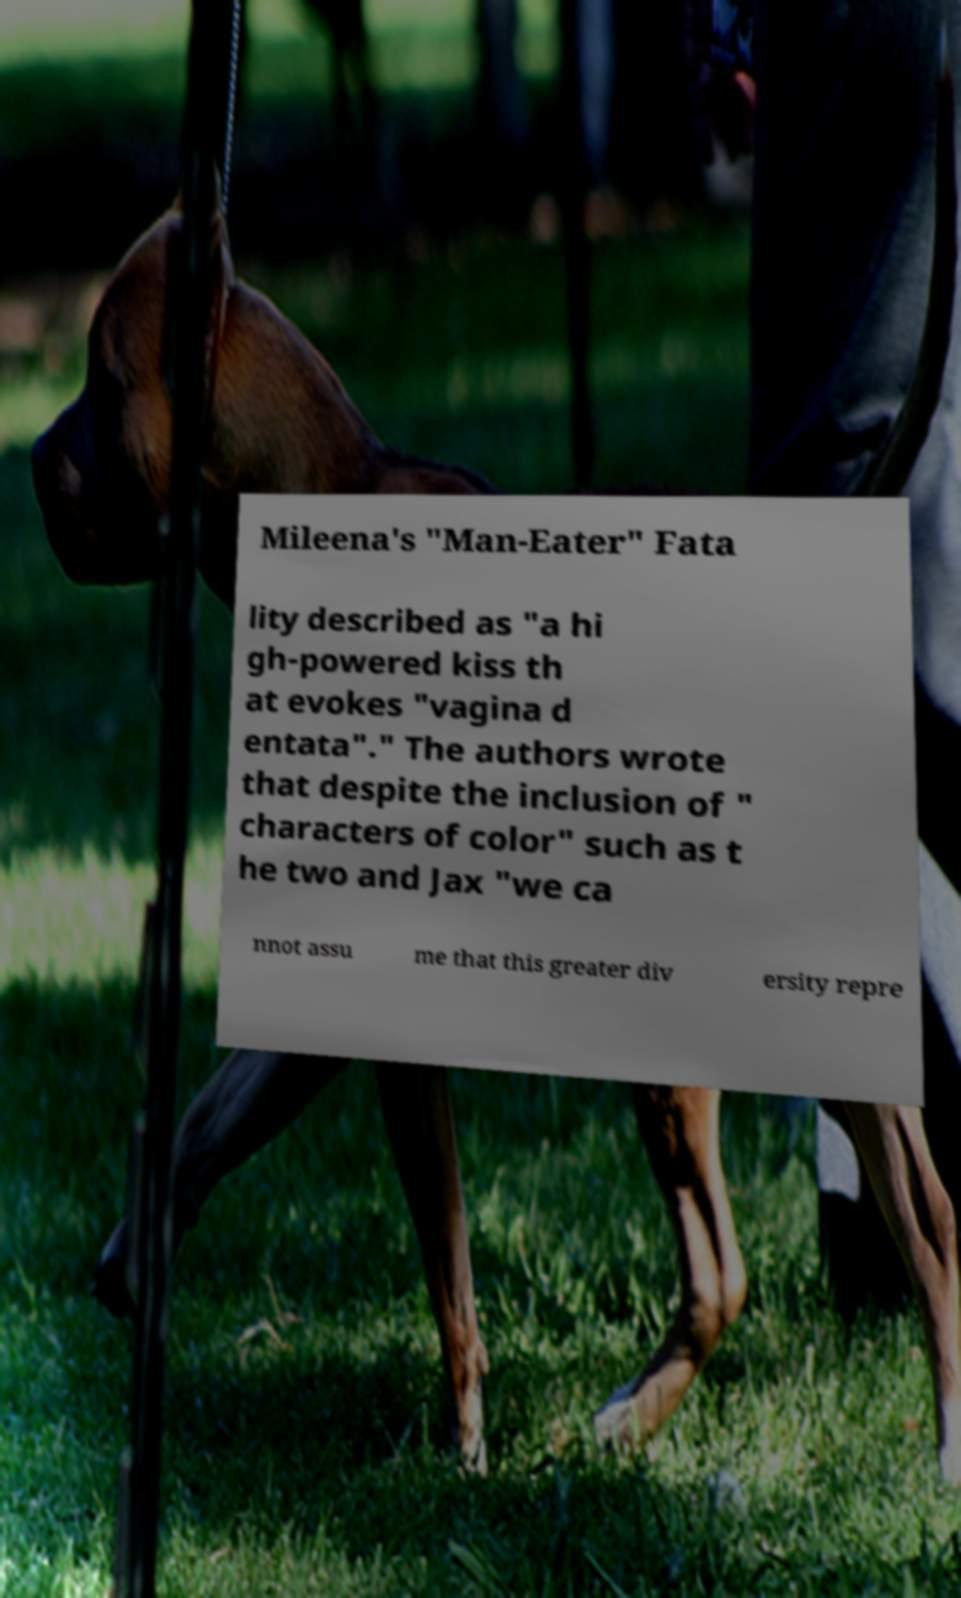There's text embedded in this image that I need extracted. Can you transcribe it verbatim? Mileena's "Man-Eater" Fata lity described as "a hi gh-powered kiss th at evokes "vagina d entata"." The authors wrote that despite the inclusion of " characters of color" such as t he two and Jax "we ca nnot assu me that this greater div ersity repre 